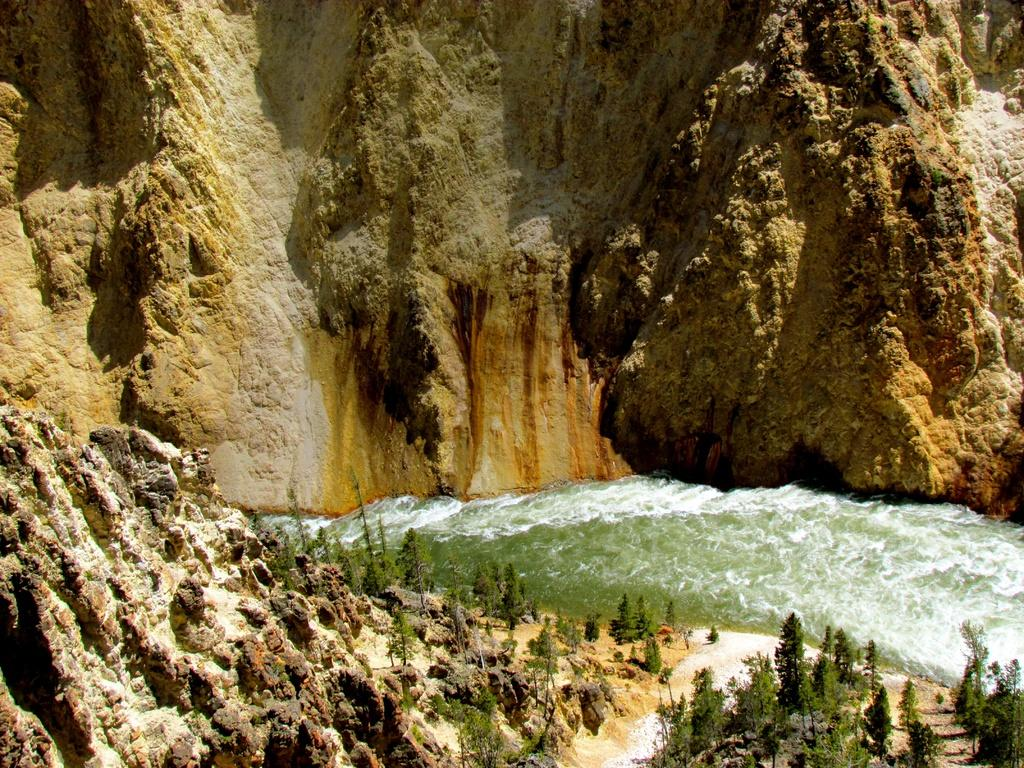What is the primary element visible in the image? There is water in the image. Where are the trees located in the image? The trees are in the right corner of the image. What can be found in the left corner of the image? There are rocks in the left corner of the image. What is visible in the background of the image? There is a mountain in the background of the image. How many ghosts can be seen floating above the water in the image? There are no ghosts present in the image; it only features water, trees, rocks, and a mountain. What type of liquid is visible in the image? The image only features water, which is a type of liquid. However, the question is misleading because the term "liquid" is already mentioned in the facts, making it an absurd question. 